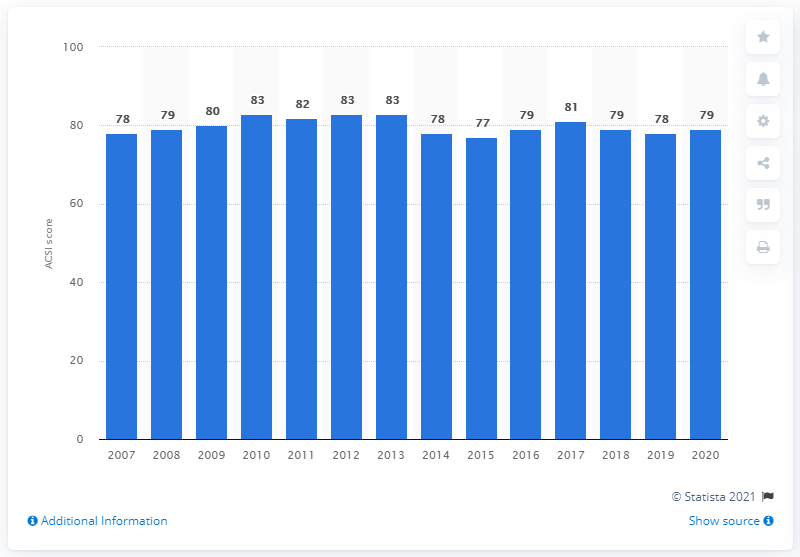Give some essential details in this illustration. In 2020, the ASCI (American Customer Satisfaction Index) score for Red Lobster restaurants in the United States was 79 out of 100. 